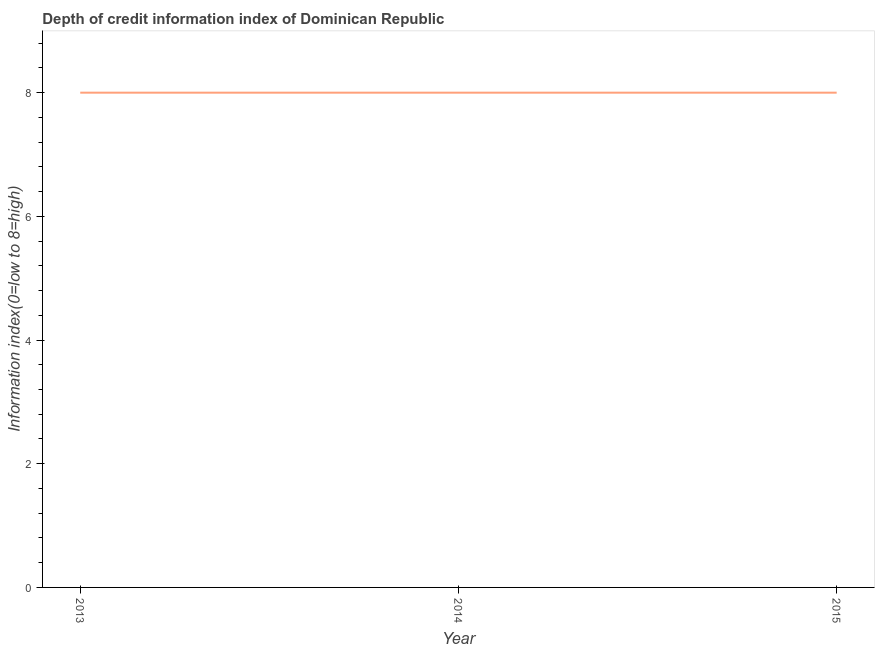What is the depth of credit information index in 2015?
Your response must be concise. 8. Across all years, what is the maximum depth of credit information index?
Provide a short and direct response. 8. Across all years, what is the minimum depth of credit information index?
Offer a very short reply. 8. In which year was the depth of credit information index minimum?
Your answer should be very brief. 2013. What is the sum of the depth of credit information index?
Your response must be concise. 24. In how many years, is the depth of credit information index greater than 4.4 ?
Provide a short and direct response. 3. Do a majority of the years between 2013 and 2014 (inclusive) have depth of credit information index greater than 4 ?
Keep it short and to the point. Yes. What is the ratio of the depth of credit information index in 2014 to that in 2015?
Your answer should be compact. 1. Is the sum of the depth of credit information index in 2013 and 2014 greater than the maximum depth of credit information index across all years?
Give a very brief answer. Yes. What is the difference between the highest and the lowest depth of credit information index?
Provide a succinct answer. 0. In how many years, is the depth of credit information index greater than the average depth of credit information index taken over all years?
Provide a succinct answer. 0. How many lines are there?
Your answer should be very brief. 1. What is the difference between two consecutive major ticks on the Y-axis?
Ensure brevity in your answer.  2. Does the graph contain grids?
Offer a very short reply. No. What is the title of the graph?
Your answer should be compact. Depth of credit information index of Dominican Republic. What is the label or title of the Y-axis?
Give a very brief answer. Information index(0=low to 8=high). What is the Information index(0=low to 8=high) of 2013?
Keep it short and to the point. 8. What is the Information index(0=low to 8=high) of 2015?
Your answer should be compact. 8. What is the difference between the Information index(0=low to 8=high) in 2013 and 2014?
Offer a very short reply. 0. What is the ratio of the Information index(0=low to 8=high) in 2013 to that in 2015?
Give a very brief answer. 1. 